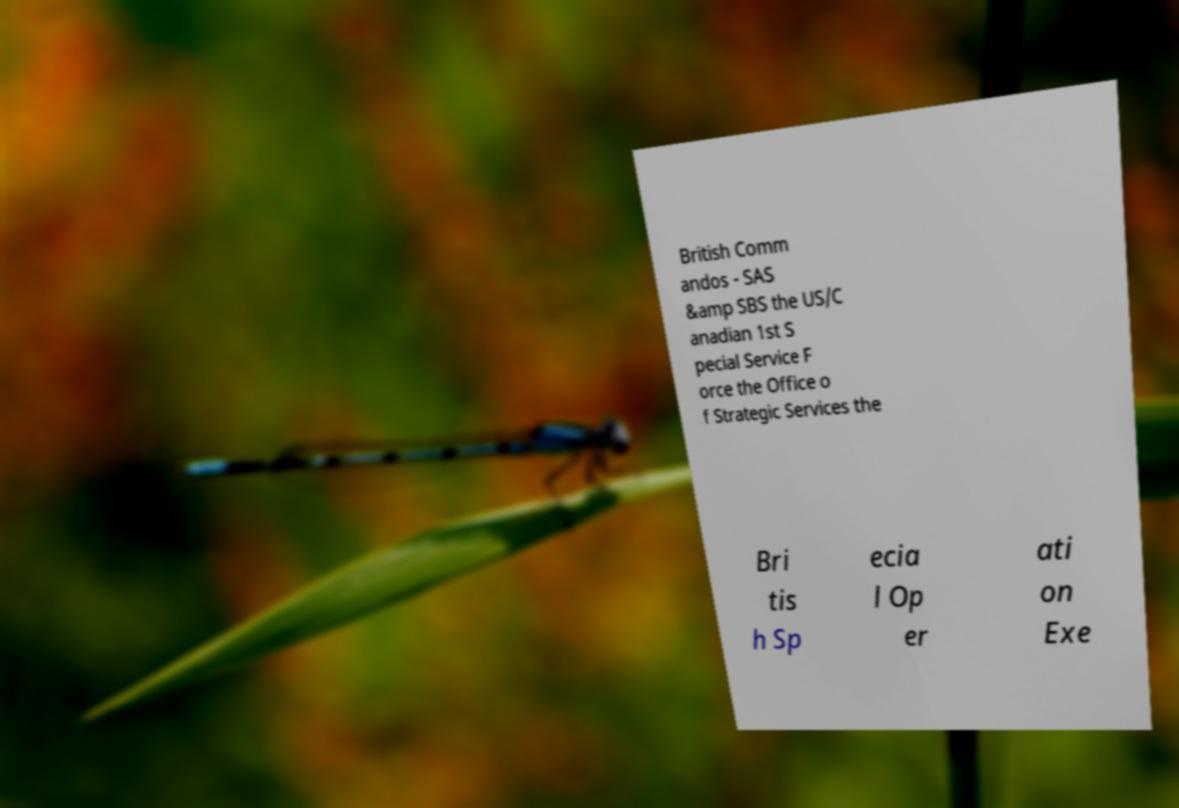Can you accurately transcribe the text from the provided image for me? British Comm andos - SAS &amp SBS the US/C anadian 1st S pecial Service F orce the Office o f Strategic Services the Bri tis h Sp ecia l Op er ati on Exe 